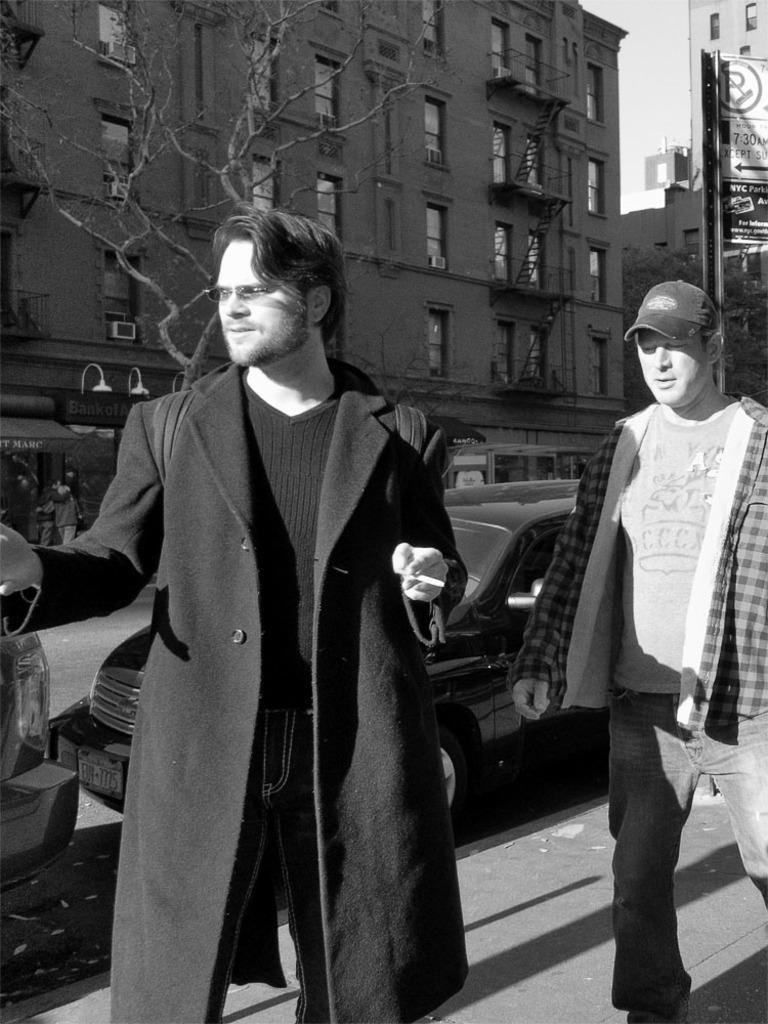How would you summarize this image in a sentence or two? This is a black and white image. In this image we can see buildings, ladders, air conditioners, street lights, stalls, motor vehicles and persons on the road. In the background we can see trees, sky and advertisements. 